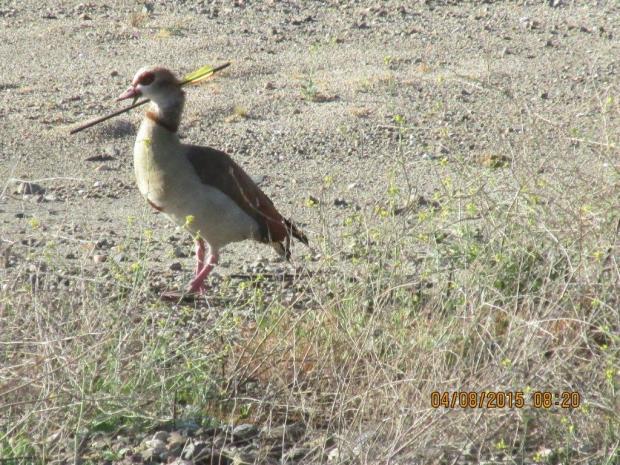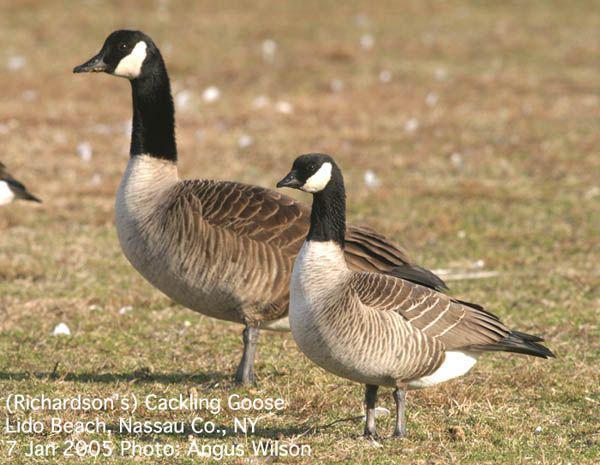The first image is the image on the left, the second image is the image on the right. Assess this claim about the two images: "There are two birds in the picture on the right.". Correct or not? Answer yes or no. Yes. 